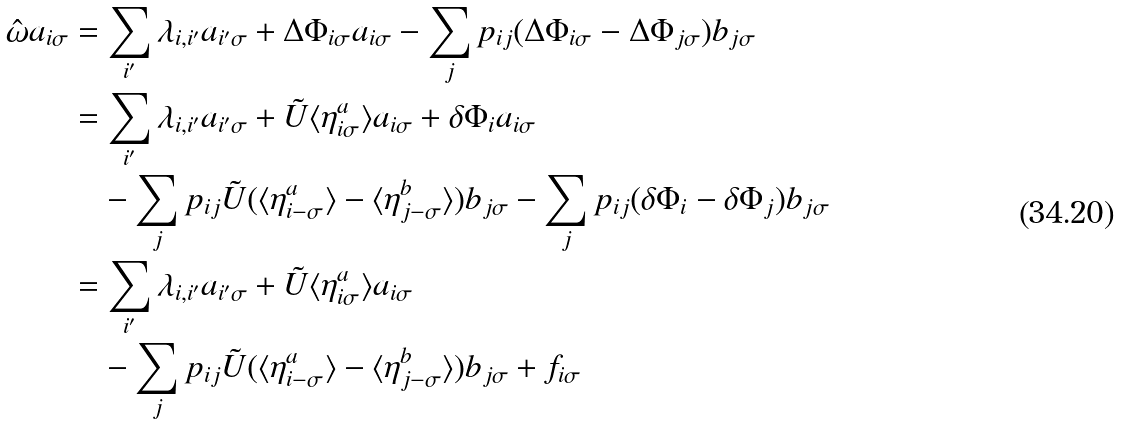<formula> <loc_0><loc_0><loc_500><loc_500>\hat { \omega } a _ { i \sigma } & = \sum _ { i ^ { \prime } } \lambda _ { i , i ^ { \prime } } a _ { i ^ { \prime } \sigma } + \Delta \Phi _ { i \sigma } a _ { i \sigma } - \sum _ { j } p _ { i j } ( \Delta \Phi _ { i \sigma } - \Delta \Phi _ { j \sigma } ) b _ { j \sigma } \\ & = \sum _ { i ^ { \prime } } \lambda _ { i , i ^ { \prime } } a _ { i ^ { \prime } \sigma } + \tilde { U } \langle \eta ^ { a } _ { i \sigma } \rangle a _ { i \sigma } + \delta \Phi _ { i } a _ { i \sigma } \\ & \quad - \sum _ { j } p _ { i j } \tilde { U } ( \langle \eta ^ { a } _ { i - \sigma } \rangle - \langle \eta ^ { b } _ { j - \sigma } \rangle ) b _ { j \sigma } - \sum _ { j } p _ { i j } ( \delta \Phi _ { i } - \delta \Phi _ { j } ) b _ { j \sigma } \\ & = \sum _ { i ^ { \prime } } \lambda _ { i , i ^ { \prime } } a _ { i ^ { \prime } \sigma } + \tilde { U } \langle \eta ^ { a } _ { i \sigma } \rangle a _ { i \sigma } \\ & \quad - \sum _ { j } p _ { i j } \tilde { U } ( \langle \eta ^ { a } _ { i - \sigma } \rangle - \langle \eta ^ { b } _ { j - \sigma } \rangle ) b _ { j \sigma } + f _ { i \sigma }</formula> 